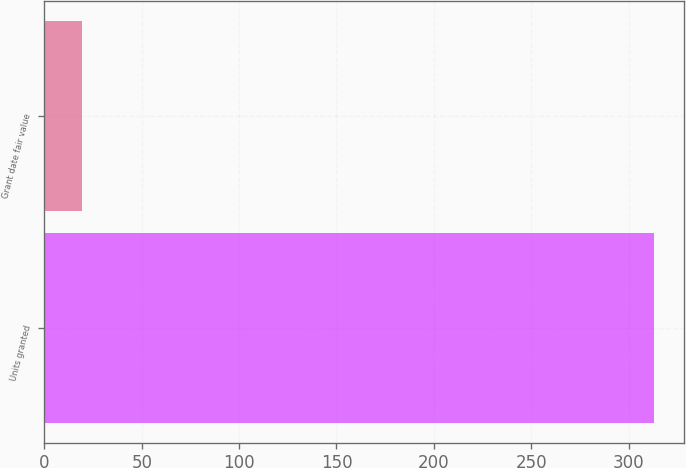Convert chart. <chart><loc_0><loc_0><loc_500><loc_500><bar_chart><fcel>Units granted<fcel>Grant date fair value<nl><fcel>313<fcel>19.08<nl></chart> 